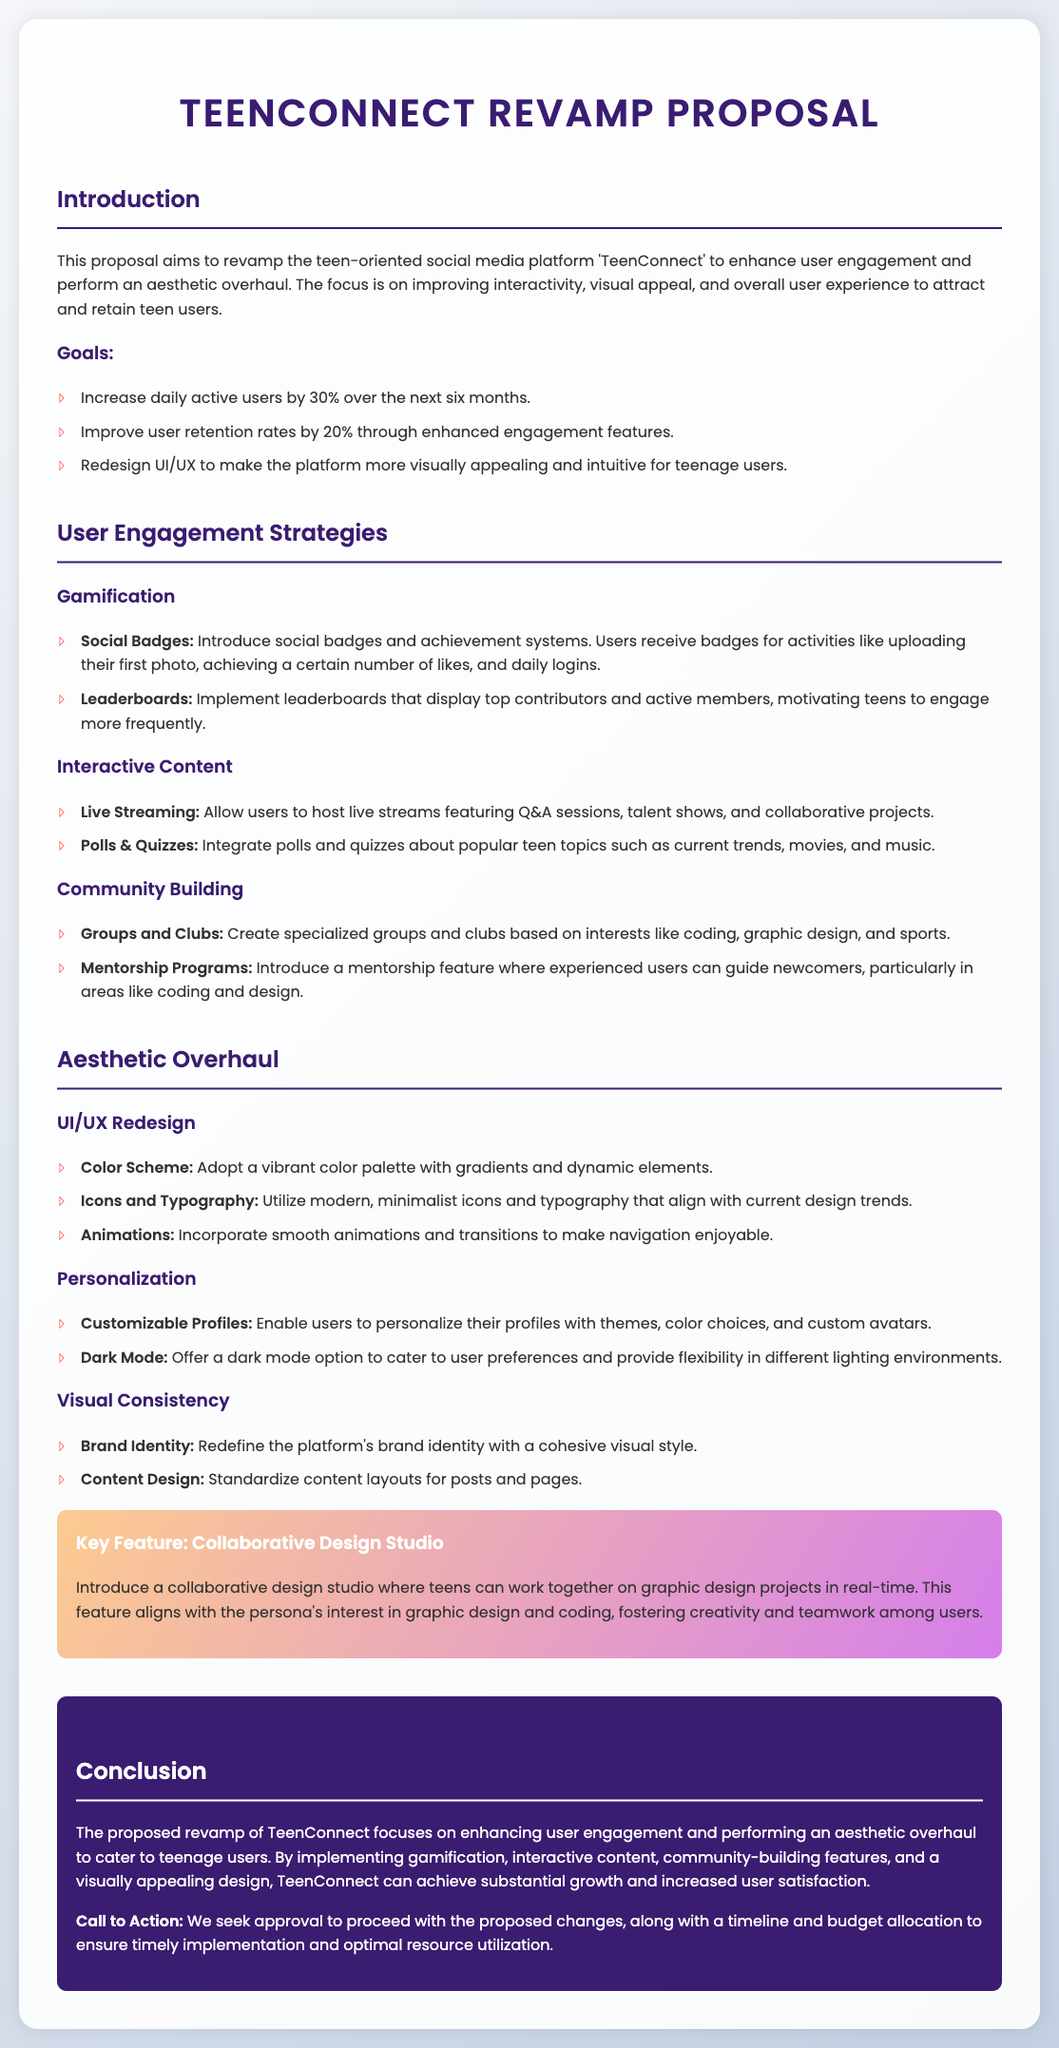What are the main goals of the proposal? The main goals of the proposal are increasing daily active users, improving user retention, and redesigning UI/UX.
Answer: Increase daily active users by 30%, Improve user retention rates by 20%, Redesign UI/UX What feature introduces a social badge system? The feature that introduces a social badge system is part of the gamification strategies in the proposal.
Answer: Gamification What is the proposed percentage increase in daily active users? The proposed percentage increase in daily active users over the next six months is specifically mentioned in the document.
Answer: 30% What type of content will be integrated into TeenConnect? The document states specific types of content that will be integrated into the platform.
Answer: Polls & Quizzes Which specific program is meant to assist newcomers? A mentorship program is specifically mentioned to assist newcomers in various areas.
Answer: Mentorship Programs What aesthetic feature is suggested for user profiles? The document suggests enabling users to personalize their profiles as a part of the aesthetic overhaul.
Answer: Customizable Profiles What is one example of interactive content mentioned? The document lists various types of interactive content that will enhance user engagement.
Answer: Live Streaming What is a key feature that aligns with graphic design interests? A collaborative design studio feature is highlighted as aligning with graphic design interests.
Answer: Collaborative Design Studio What is the background color of the conclusion section? The background color of the conclusion section is described in the design attributes of the document.
Answer: #3a1c71 